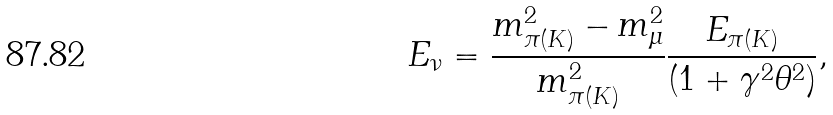Convert formula to latex. <formula><loc_0><loc_0><loc_500><loc_500>E _ { \nu } = { \frac { m ^ { 2 } _ { \pi ( K ) } - m ^ { 2 } _ { \mu } } { m ^ { 2 } _ { \pi ( K ) } } } \frac { E _ { \pi ( K ) } } { ( 1 + \gamma ^ { 2 } \theta ^ { 2 } ) } ,</formula> 